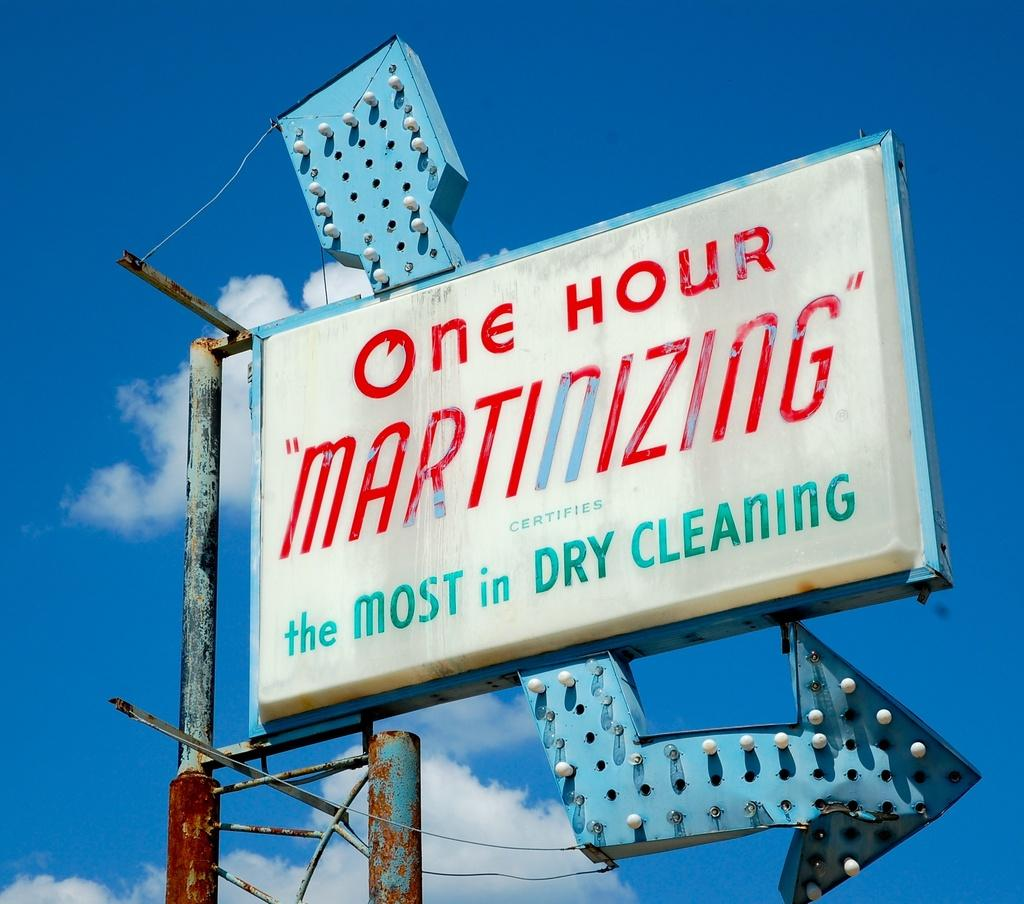Provide a one-sentence caption for the provided image. A sign for a one hour dry cleaning business. 